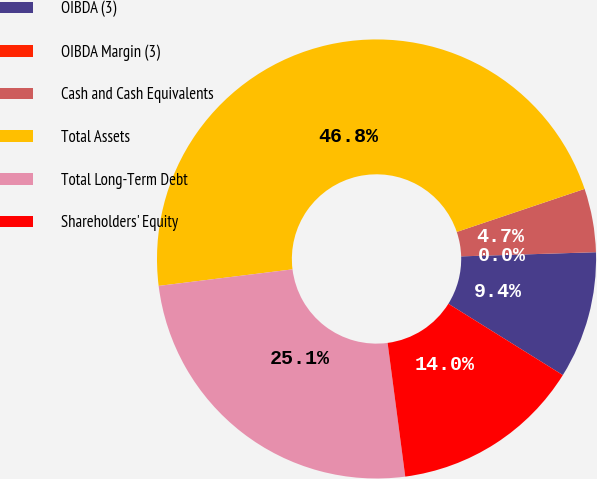<chart> <loc_0><loc_0><loc_500><loc_500><pie_chart><fcel>OIBDA (3)<fcel>OIBDA Margin (3)<fcel>Cash and Cash Equivalents<fcel>Total Assets<fcel>Total Long-Term Debt<fcel>Shareholders' Equity<nl><fcel>9.36%<fcel>0.0%<fcel>4.68%<fcel>46.79%<fcel>25.13%<fcel>14.04%<nl></chart> 